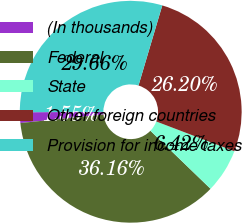Convert chart. <chart><loc_0><loc_0><loc_500><loc_500><pie_chart><fcel>(In thousands)<fcel>Federal<fcel>State<fcel>Other foreign countries<fcel>Provision for income taxes<nl><fcel>1.55%<fcel>36.16%<fcel>6.42%<fcel>26.2%<fcel>29.66%<nl></chart> 